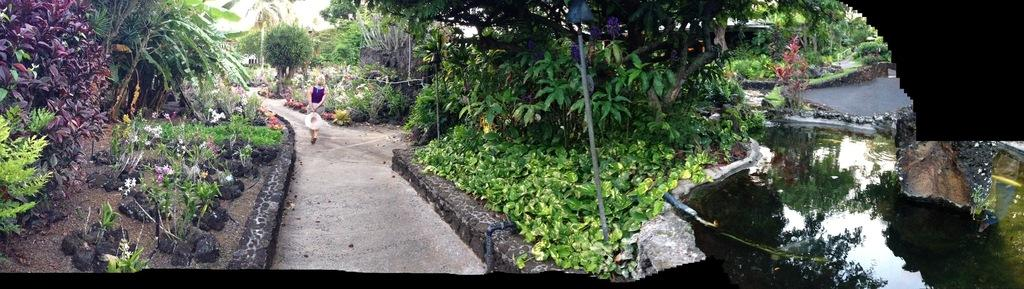What type of vegetation can be seen in the image? There are trees and plants in the image. What natural element is visible in the image? There is water visible in the image. What type of flora is present in the image? There are flowers in the image. What type of terrain is present in the image? There is sand in the image. Are there any people in the image? Yes, there are people in the image. Where is the wax sculpture of a zebra located in the image? There is no wax sculpture of a zebra present in the image. What type of hall can be seen in the image? There is no hall present in the image. 